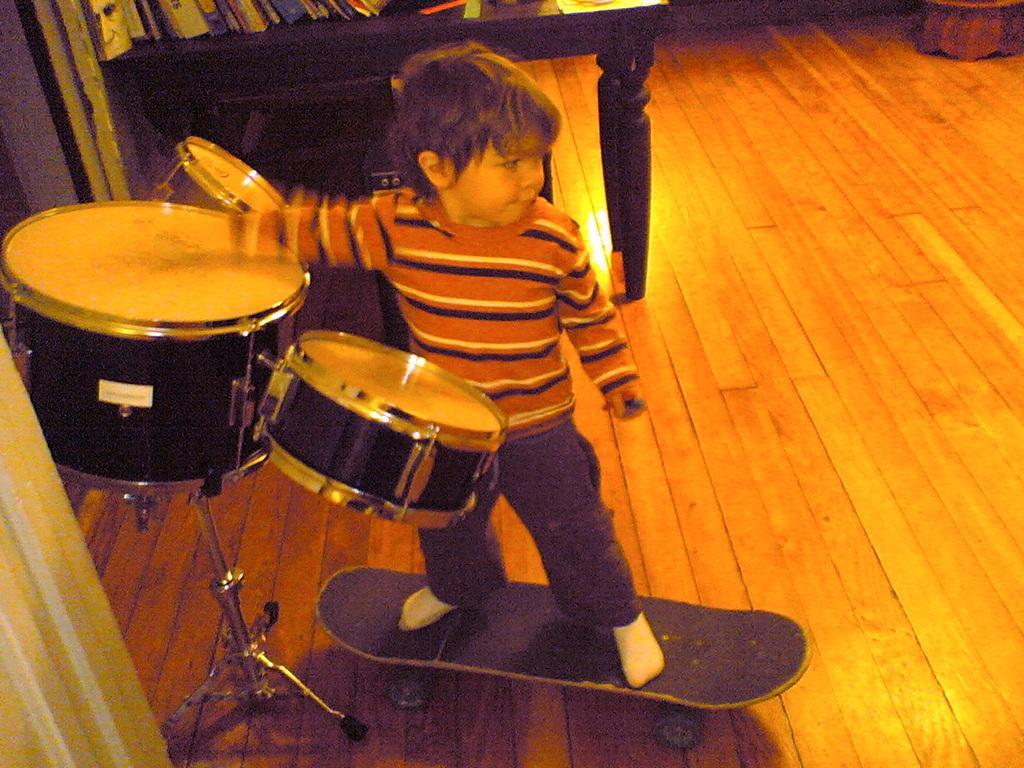Could you give a brief overview of what you see in this image? In this image we can see a boy standing on a skateboard and playing a musical instrument. The boy is holding an object. Behind the boy we can see books on a table and a wall. We can see the floor. In the bottom left we can see a pillar. 